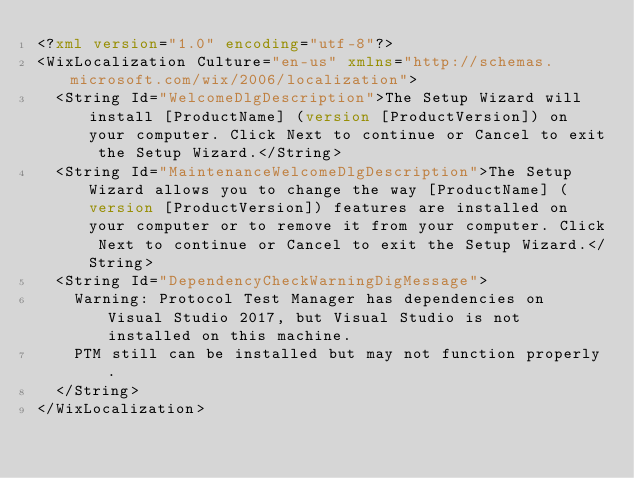Convert code to text. <code><loc_0><loc_0><loc_500><loc_500><_XML_><?xml version="1.0" encoding="utf-8"?>
<WixLocalization Culture="en-us" xmlns="http://schemas.microsoft.com/wix/2006/localization">
  <String Id="WelcomeDlgDescription">The Setup Wizard will install [ProductName] (version [ProductVersion]) on your computer. Click Next to continue or Cancel to exit the Setup Wizard.</String>
  <String Id="MaintenanceWelcomeDlgDescription">The Setup Wizard allows you to change the way [ProductName] (version [ProductVersion]) features are installed on your computer or to remove it from your computer. Click Next to continue or Cancel to exit the Setup Wizard.</String>
  <String Id="DependencyCheckWarningDigMessage">
	Warning: Protocol Test Manager has dependencies on Visual Studio 2017, but Visual Studio is not installed on this machine. 
	PTM still can be installed but may not function properly.
  </String>
</WixLocalization></code> 